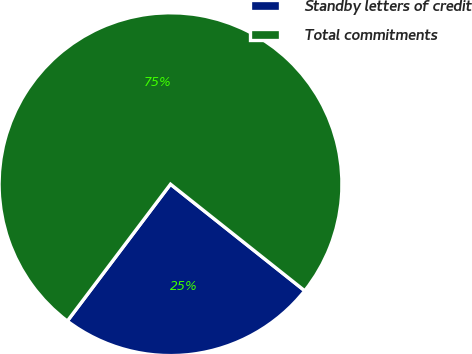Convert chart to OTSL. <chart><loc_0><loc_0><loc_500><loc_500><pie_chart><fcel>Standby letters of credit<fcel>Total commitments<nl><fcel>24.6%<fcel>75.4%<nl></chart> 